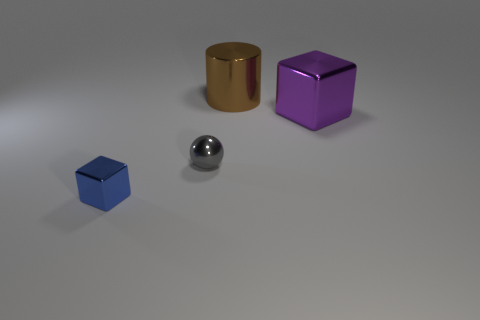What shape is the thing that is to the left of the brown metal object and to the right of the blue block?
Make the answer very short. Sphere. There is a purple object that is the same material as the tiny blue thing; what is its shape?
Offer a terse response. Cube. Are there any small gray metal balls?
Offer a very short reply. Yes. Is there a small shiny object that is in front of the tiny metallic thing on the right side of the tiny metallic cube?
Your response must be concise. Yes. What is the material of the other object that is the same shape as the large purple shiny object?
Your answer should be compact. Metal. Are there more big cylinders than small yellow objects?
Ensure brevity in your answer.  Yes. There is a tiny metal ball; is it the same color as the metal block to the right of the blue metallic object?
Offer a terse response. No. The object that is right of the gray shiny ball and to the left of the purple block is what color?
Ensure brevity in your answer.  Brown. What number of other objects are there of the same material as the brown cylinder?
Provide a succinct answer. 3. Is the number of big purple objects less than the number of tiny shiny things?
Offer a terse response. Yes. 